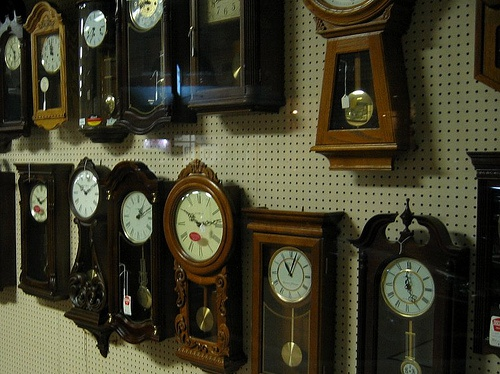Describe the objects in this image and their specific colors. I can see clock in black, maroon, olive, and gray tones, clock in black, gray, and darkgreen tones, clock in black, beige, darkgray, and gray tones, clock in black, olive, gray, and tan tones, and clock in black, olive, and darkgray tones in this image. 